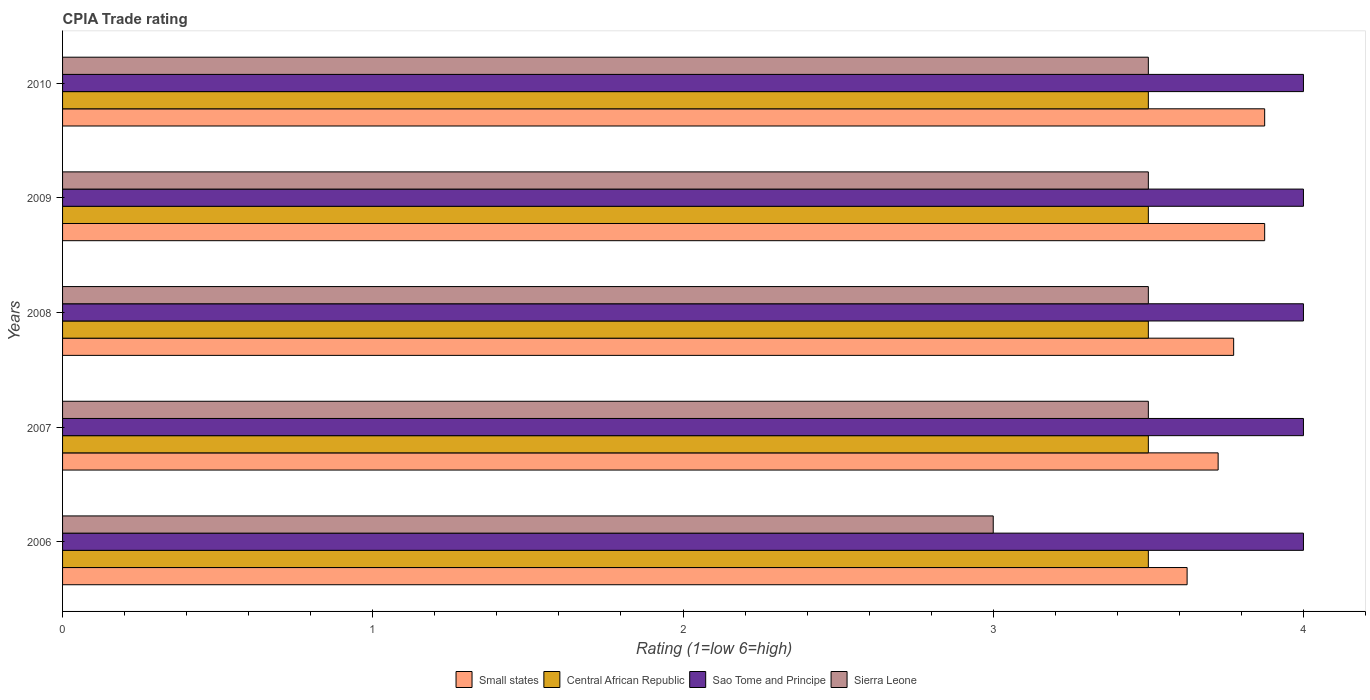How many different coloured bars are there?
Your answer should be compact. 4. How many groups of bars are there?
Your response must be concise. 5. Are the number of bars per tick equal to the number of legend labels?
Give a very brief answer. Yes. How many bars are there on the 1st tick from the top?
Keep it short and to the point. 4. What is the label of the 4th group of bars from the top?
Ensure brevity in your answer.  2007. In how many cases, is the number of bars for a given year not equal to the number of legend labels?
Offer a terse response. 0. What is the CPIA rating in Central African Republic in 2008?
Your answer should be compact. 3.5. Across all years, what is the minimum CPIA rating in Small states?
Your answer should be very brief. 3.62. In which year was the CPIA rating in Small states maximum?
Your answer should be very brief. 2009. In which year was the CPIA rating in Small states minimum?
Your answer should be very brief. 2006. What is the total CPIA rating in Sierra Leone in the graph?
Provide a succinct answer. 17. What is the average CPIA rating in Central African Republic per year?
Offer a very short reply. 3.5. In how many years, is the CPIA rating in Sierra Leone greater than 3.6 ?
Provide a succinct answer. 0. What is the ratio of the CPIA rating in Sierra Leone in 2006 to that in 2007?
Make the answer very short. 0.86. Is it the case that in every year, the sum of the CPIA rating in Central African Republic and CPIA rating in Sao Tome and Principe is greater than the sum of CPIA rating in Sierra Leone and CPIA rating in Small states?
Offer a terse response. Yes. What does the 2nd bar from the top in 2008 represents?
Provide a succinct answer. Sao Tome and Principe. What does the 2nd bar from the bottom in 2009 represents?
Make the answer very short. Central African Republic. How many bars are there?
Offer a very short reply. 20. Does the graph contain grids?
Provide a short and direct response. No. Where does the legend appear in the graph?
Give a very brief answer. Bottom center. How many legend labels are there?
Your answer should be very brief. 4. What is the title of the graph?
Keep it short and to the point. CPIA Trade rating. What is the label or title of the Y-axis?
Keep it short and to the point. Years. What is the Rating (1=low 6=high) in Small states in 2006?
Your response must be concise. 3.62. What is the Rating (1=low 6=high) in Sao Tome and Principe in 2006?
Offer a very short reply. 4. What is the Rating (1=low 6=high) in Sierra Leone in 2006?
Keep it short and to the point. 3. What is the Rating (1=low 6=high) of Small states in 2007?
Offer a very short reply. 3.73. What is the Rating (1=low 6=high) of Central African Republic in 2007?
Make the answer very short. 3.5. What is the Rating (1=low 6=high) in Small states in 2008?
Ensure brevity in your answer.  3.77. What is the Rating (1=low 6=high) in Central African Republic in 2008?
Offer a very short reply. 3.5. What is the Rating (1=low 6=high) of Sierra Leone in 2008?
Your response must be concise. 3.5. What is the Rating (1=low 6=high) in Small states in 2009?
Your answer should be very brief. 3.88. What is the Rating (1=low 6=high) in Central African Republic in 2009?
Keep it short and to the point. 3.5. What is the Rating (1=low 6=high) in Small states in 2010?
Your answer should be compact. 3.88. What is the Rating (1=low 6=high) of Central African Republic in 2010?
Offer a terse response. 3.5. What is the Rating (1=low 6=high) in Sierra Leone in 2010?
Ensure brevity in your answer.  3.5. Across all years, what is the maximum Rating (1=low 6=high) of Small states?
Your answer should be compact. 3.88. Across all years, what is the maximum Rating (1=low 6=high) of Sierra Leone?
Provide a short and direct response. 3.5. Across all years, what is the minimum Rating (1=low 6=high) of Small states?
Keep it short and to the point. 3.62. Across all years, what is the minimum Rating (1=low 6=high) in Central African Republic?
Keep it short and to the point. 3.5. Across all years, what is the minimum Rating (1=low 6=high) in Sao Tome and Principe?
Give a very brief answer. 4. Across all years, what is the minimum Rating (1=low 6=high) of Sierra Leone?
Give a very brief answer. 3. What is the total Rating (1=low 6=high) in Small states in the graph?
Keep it short and to the point. 18.88. What is the total Rating (1=low 6=high) in Sao Tome and Principe in the graph?
Your answer should be very brief. 20. What is the difference between the Rating (1=low 6=high) of Small states in 2006 and that in 2007?
Your answer should be compact. -0.1. What is the difference between the Rating (1=low 6=high) of Sao Tome and Principe in 2006 and that in 2007?
Provide a succinct answer. 0. What is the difference between the Rating (1=low 6=high) of Sierra Leone in 2006 and that in 2007?
Provide a short and direct response. -0.5. What is the difference between the Rating (1=low 6=high) of Small states in 2006 and that in 2008?
Your answer should be very brief. -0.15. What is the difference between the Rating (1=low 6=high) of Central African Republic in 2006 and that in 2008?
Ensure brevity in your answer.  0. What is the difference between the Rating (1=low 6=high) in Sao Tome and Principe in 2006 and that in 2008?
Provide a succinct answer. 0. What is the difference between the Rating (1=low 6=high) of Sierra Leone in 2006 and that in 2008?
Make the answer very short. -0.5. What is the difference between the Rating (1=low 6=high) of Small states in 2006 and that in 2009?
Keep it short and to the point. -0.25. What is the difference between the Rating (1=low 6=high) of Sao Tome and Principe in 2006 and that in 2009?
Offer a very short reply. 0. What is the difference between the Rating (1=low 6=high) of Sierra Leone in 2006 and that in 2009?
Your answer should be compact. -0.5. What is the difference between the Rating (1=low 6=high) of Small states in 2006 and that in 2010?
Your answer should be very brief. -0.25. What is the difference between the Rating (1=low 6=high) in Central African Republic in 2006 and that in 2010?
Provide a succinct answer. 0. What is the difference between the Rating (1=low 6=high) of Sierra Leone in 2007 and that in 2008?
Provide a succinct answer. 0. What is the difference between the Rating (1=low 6=high) in Sao Tome and Principe in 2007 and that in 2009?
Offer a terse response. 0. What is the difference between the Rating (1=low 6=high) of Central African Republic in 2007 and that in 2010?
Keep it short and to the point. 0. What is the difference between the Rating (1=low 6=high) in Central African Republic in 2008 and that in 2009?
Make the answer very short. 0. What is the difference between the Rating (1=low 6=high) in Small states in 2008 and that in 2010?
Your response must be concise. -0.1. What is the difference between the Rating (1=low 6=high) of Sao Tome and Principe in 2008 and that in 2010?
Offer a terse response. 0. What is the difference between the Rating (1=low 6=high) of Central African Republic in 2009 and that in 2010?
Keep it short and to the point. 0. What is the difference between the Rating (1=low 6=high) of Sierra Leone in 2009 and that in 2010?
Provide a short and direct response. 0. What is the difference between the Rating (1=low 6=high) in Small states in 2006 and the Rating (1=low 6=high) in Central African Republic in 2007?
Make the answer very short. 0.12. What is the difference between the Rating (1=low 6=high) of Small states in 2006 and the Rating (1=low 6=high) of Sao Tome and Principe in 2007?
Give a very brief answer. -0.38. What is the difference between the Rating (1=low 6=high) in Small states in 2006 and the Rating (1=low 6=high) in Sierra Leone in 2007?
Offer a terse response. 0.12. What is the difference between the Rating (1=low 6=high) in Central African Republic in 2006 and the Rating (1=low 6=high) in Sao Tome and Principe in 2007?
Your answer should be very brief. -0.5. What is the difference between the Rating (1=low 6=high) in Small states in 2006 and the Rating (1=low 6=high) in Sao Tome and Principe in 2008?
Make the answer very short. -0.38. What is the difference between the Rating (1=low 6=high) of Central African Republic in 2006 and the Rating (1=low 6=high) of Sierra Leone in 2008?
Offer a terse response. 0. What is the difference between the Rating (1=low 6=high) of Small states in 2006 and the Rating (1=low 6=high) of Sao Tome and Principe in 2009?
Make the answer very short. -0.38. What is the difference between the Rating (1=low 6=high) in Small states in 2006 and the Rating (1=low 6=high) in Sierra Leone in 2009?
Your answer should be very brief. 0.12. What is the difference between the Rating (1=low 6=high) of Small states in 2006 and the Rating (1=low 6=high) of Sao Tome and Principe in 2010?
Offer a terse response. -0.38. What is the difference between the Rating (1=low 6=high) in Small states in 2006 and the Rating (1=low 6=high) in Sierra Leone in 2010?
Provide a succinct answer. 0.12. What is the difference between the Rating (1=low 6=high) of Central African Republic in 2006 and the Rating (1=low 6=high) of Sao Tome and Principe in 2010?
Offer a very short reply. -0.5. What is the difference between the Rating (1=low 6=high) in Central African Republic in 2006 and the Rating (1=low 6=high) in Sierra Leone in 2010?
Give a very brief answer. 0. What is the difference between the Rating (1=low 6=high) in Sao Tome and Principe in 2006 and the Rating (1=low 6=high) in Sierra Leone in 2010?
Your response must be concise. 0.5. What is the difference between the Rating (1=low 6=high) of Small states in 2007 and the Rating (1=low 6=high) of Central African Republic in 2008?
Make the answer very short. 0.23. What is the difference between the Rating (1=low 6=high) in Small states in 2007 and the Rating (1=low 6=high) in Sao Tome and Principe in 2008?
Keep it short and to the point. -0.28. What is the difference between the Rating (1=low 6=high) of Small states in 2007 and the Rating (1=low 6=high) of Sierra Leone in 2008?
Ensure brevity in your answer.  0.23. What is the difference between the Rating (1=low 6=high) of Central African Republic in 2007 and the Rating (1=low 6=high) of Sao Tome and Principe in 2008?
Provide a short and direct response. -0.5. What is the difference between the Rating (1=low 6=high) in Central African Republic in 2007 and the Rating (1=low 6=high) in Sierra Leone in 2008?
Ensure brevity in your answer.  0. What is the difference between the Rating (1=low 6=high) of Small states in 2007 and the Rating (1=low 6=high) of Central African Republic in 2009?
Make the answer very short. 0.23. What is the difference between the Rating (1=low 6=high) of Small states in 2007 and the Rating (1=low 6=high) of Sao Tome and Principe in 2009?
Your answer should be very brief. -0.28. What is the difference between the Rating (1=low 6=high) in Small states in 2007 and the Rating (1=low 6=high) in Sierra Leone in 2009?
Your response must be concise. 0.23. What is the difference between the Rating (1=low 6=high) of Sao Tome and Principe in 2007 and the Rating (1=low 6=high) of Sierra Leone in 2009?
Offer a terse response. 0.5. What is the difference between the Rating (1=low 6=high) in Small states in 2007 and the Rating (1=low 6=high) in Central African Republic in 2010?
Provide a succinct answer. 0.23. What is the difference between the Rating (1=low 6=high) in Small states in 2007 and the Rating (1=low 6=high) in Sao Tome and Principe in 2010?
Ensure brevity in your answer.  -0.28. What is the difference between the Rating (1=low 6=high) of Small states in 2007 and the Rating (1=low 6=high) of Sierra Leone in 2010?
Offer a very short reply. 0.23. What is the difference between the Rating (1=low 6=high) in Central African Republic in 2007 and the Rating (1=low 6=high) in Sierra Leone in 2010?
Offer a terse response. 0. What is the difference between the Rating (1=low 6=high) of Small states in 2008 and the Rating (1=low 6=high) of Central African Republic in 2009?
Provide a short and direct response. 0.28. What is the difference between the Rating (1=low 6=high) in Small states in 2008 and the Rating (1=low 6=high) in Sao Tome and Principe in 2009?
Offer a very short reply. -0.23. What is the difference between the Rating (1=low 6=high) in Small states in 2008 and the Rating (1=low 6=high) in Sierra Leone in 2009?
Your answer should be compact. 0.28. What is the difference between the Rating (1=low 6=high) in Central African Republic in 2008 and the Rating (1=low 6=high) in Sao Tome and Principe in 2009?
Give a very brief answer. -0.5. What is the difference between the Rating (1=low 6=high) in Small states in 2008 and the Rating (1=low 6=high) in Central African Republic in 2010?
Keep it short and to the point. 0.28. What is the difference between the Rating (1=low 6=high) of Small states in 2008 and the Rating (1=low 6=high) of Sao Tome and Principe in 2010?
Offer a very short reply. -0.23. What is the difference between the Rating (1=low 6=high) of Small states in 2008 and the Rating (1=low 6=high) of Sierra Leone in 2010?
Make the answer very short. 0.28. What is the difference between the Rating (1=low 6=high) of Sao Tome and Principe in 2008 and the Rating (1=low 6=high) of Sierra Leone in 2010?
Offer a terse response. 0.5. What is the difference between the Rating (1=low 6=high) in Small states in 2009 and the Rating (1=low 6=high) in Central African Republic in 2010?
Make the answer very short. 0.38. What is the difference between the Rating (1=low 6=high) of Small states in 2009 and the Rating (1=low 6=high) of Sao Tome and Principe in 2010?
Make the answer very short. -0.12. What is the difference between the Rating (1=low 6=high) of Central African Republic in 2009 and the Rating (1=low 6=high) of Sao Tome and Principe in 2010?
Your response must be concise. -0.5. What is the difference between the Rating (1=low 6=high) of Sao Tome and Principe in 2009 and the Rating (1=low 6=high) of Sierra Leone in 2010?
Offer a terse response. 0.5. What is the average Rating (1=low 6=high) of Small states per year?
Your answer should be compact. 3.77. What is the average Rating (1=low 6=high) in Sierra Leone per year?
Your response must be concise. 3.4. In the year 2006, what is the difference between the Rating (1=low 6=high) of Small states and Rating (1=low 6=high) of Central African Republic?
Ensure brevity in your answer.  0.12. In the year 2006, what is the difference between the Rating (1=low 6=high) of Small states and Rating (1=low 6=high) of Sao Tome and Principe?
Make the answer very short. -0.38. In the year 2006, what is the difference between the Rating (1=low 6=high) of Central African Republic and Rating (1=low 6=high) of Sao Tome and Principe?
Keep it short and to the point. -0.5. In the year 2007, what is the difference between the Rating (1=low 6=high) of Small states and Rating (1=low 6=high) of Central African Republic?
Make the answer very short. 0.23. In the year 2007, what is the difference between the Rating (1=low 6=high) in Small states and Rating (1=low 6=high) in Sao Tome and Principe?
Your response must be concise. -0.28. In the year 2007, what is the difference between the Rating (1=low 6=high) of Small states and Rating (1=low 6=high) of Sierra Leone?
Ensure brevity in your answer.  0.23. In the year 2007, what is the difference between the Rating (1=low 6=high) of Central African Republic and Rating (1=low 6=high) of Sao Tome and Principe?
Provide a short and direct response. -0.5. In the year 2007, what is the difference between the Rating (1=low 6=high) in Central African Republic and Rating (1=low 6=high) in Sierra Leone?
Provide a succinct answer. 0. In the year 2007, what is the difference between the Rating (1=low 6=high) in Sao Tome and Principe and Rating (1=low 6=high) in Sierra Leone?
Provide a short and direct response. 0.5. In the year 2008, what is the difference between the Rating (1=low 6=high) in Small states and Rating (1=low 6=high) in Central African Republic?
Make the answer very short. 0.28. In the year 2008, what is the difference between the Rating (1=low 6=high) in Small states and Rating (1=low 6=high) in Sao Tome and Principe?
Your response must be concise. -0.23. In the year 2008, what is the difference between the Rating (1=low 6=high) in Small states and Rating (1=low 6=high) in Sierra Leone?
Your answer should be compact. 0.28. In the year 2008, what is the difference between the Rating (1=low 6=high) in Central African Republic and Rating (1=low 6=high) in Sao Tome and Principe?
Your response must be concise. -0.5. In the year 2008, what is the difference between the Rating (1=low 6=high) of Sao Tome and Principe and Rating (1=low 6=high) of Sierra Leone?
Your answer should be compact. 0.5. In the year 2009, what is the difference between the Rating (1=low 6=high) of Small states and Rating (1=low 6=high) of Sao Tome and Principe?
Give a very brief answer. -0.12. In the year 2009, what is the difference between the Rating (1=low 6=high) in Small states and Rating (1=low 6=high) in Sierra Leone?
Offer a very short reply. 0.38. In the year 2009, what is the difference between the Rating (1=low 6=high) of Central African Republic and Rating (1=low 6=high) of Sao Tome and Principe?
Your answer should be very brief. -0.5. In the year 2009, what is the difference between the Rating (1=low 6=high) in Central African Republic and Rating (1=low 6=high) in Sierra Leone?
Provide a short and direct response. 0. In the year 2009, what is the difference between the Rating (1=low 6=high) of Sao Tome and Principe and Rating (1=low 6=high) of Sierra Leone?
Provide a short and direct response. 0.5. In the year 2010, what is the difference between the Rating (1=low 6=high) in Small states and Rating (1=low 6=high) in Central African Republic?
Make the answer very short. 0.38. In the year 2010, what is the difference between the Rating (1=low 6=high) in Small states and Rating (1=low 6=high) in Sao Tome and Principe?
Offer a very short reply. -0.12. In the year 2010, what is the difference between the Rating (1=low 6=high) in Small states and Rating (1=low 6=high) in Sierra Leone?
Your answer should be compact. 0.38. In the year 2010, what is the difference between the Rating (1=low 6=high) of Central African Republic and Rating (1=low 6=high) of Sierra Leone?
Offer a very short reply. 0. In the year 2010, what is the difference between the Rating (1=low 6=high) of Sao Tome and Principe and Rating (1=low 6=high) of Sierra Leone?
Keep it short and to the point. 0.5. What is the ratio of the Rating (1=low 6=high) in Small states in 2006 to that in 2007?
Give a very brief answer. 0.97. What is the ratio of the Rating (1=low 6=high) in Central African Republic in 2006 to that in 2007?
Keep it short and to the point. 1. What is the ratio of the Rating (1=low 6=high) in Small states in 2006 to that in 2008?
Your response must be concise. 0.96. What is the ratio of the Rating (1=low 6=high) of Sao Tome and Principe in 2006 to that in 2008?
Give a very brief answer. 1. What is the ratio of the Rating (1=low 6=high) of Sierra Leone in 2006 to that in 2008?
Ensure brevity in your answer.  0.86. What is the ratio of the Rating (1=low 6=high) of Small states in 2006 to that in 2009?
Ensure brevity in your answer.  0.94. What is the ratio of the Rating (1=low 6=high) of Central African Republic in 2006 to that in 2009?
Keep it short and to the point. 1. What is the ratio of the Rating (1=low 6=high) in Sierra Leone in 2006 to that in 2009?
Give a very brief answer. 0.86. What is the ratio of the Rating (1=low 6=high) in Small states in 2006 to that in 2010?
Your answer should be very brief. 0.94. What is the ratio of the Rating (1=low 6=high) of Central African Republic in 2006 to that in 2010?
Your response must be concise. 1. What is the ratio of the Rating (1=low 6=high) of Small states in 2007 to that in 2008?
Make the answer very short. 0.99. What is the ratio of the Rating (1=low 6=high) in Sao Tome and Principe in 2007 to that in 2008?
Make the answer very short. 1. What is the ratio of the Rating (1=low 6=high) in Sierra Leone in 2007 to that in 2008?
Offer a terse response. 1. What is the ratio of the Rating (1=low 6=high) of Small states in 2007 to that in 2009?
Provide a succinct answer. 0.96. What is the ratio of the Rating (1=low 6=high) in Central African Republic in 2007 to that in 2009?
Give a very brief answer. 1. What is the ratio of the Rating (1=low 6=high) of Small states in 2007 to that in 2010?
Keep it short and to the point. 0.96. What is the ratio of the Rating (1=low 6=high) of Central African Republic in 2007 to that in 2010?
Make the answer very short. 1. What is the ratio of the Rating (1=low 6=high) of Sao Tome and Principe in 2007 to that in 2010?
Offer a terse response. 1. What is the ratio of the Rating (1=low 6=high) of Sierra Leone in 2007 to that in 2010?
Offer a very short reply. 1. What is the ratio of the Rating (1=low 6=high) in Small states in 2008 to that in 2009?
Make the answer very short. 0.97. What is the ratio of the Rating (1=low 6=high) of Sierra Leone in 2008 to that in 2009?
Your answer should be compact. 1. What is the ratio of the Rating (1=low 6=high) in Small states in 2008 to that in 2010?
Keep it short and to the point. 0.97. What is the ratio of the Rating (1=low 6=high) in Central African Republic in 2008 to that in 2010?
Your response must be concise. 1. What is the ratio of the Rating (1=low 6=high) of Sao Tome and Principe in 2008 to that in 2010?
Give a very brief answer. 1. What is the ratio of the Rating (1=low 6=high) in Small states in 2009 to that in 2010?
Your response must be concise. 1. What is the ratio of the Rating (1=low 6=high) in Sao Tome and Principe in 2009 to that in 2010?
Keep it short and to the point. 1. What is the difference between the highest and the second highest Rating (1=low 6=high) of Small states?
Your answer should be very brief. 0. What is the difference between the highest and the second highest Rating (1=low 6=high) of Sierra Leone?
Offer a very short reply. 0. What is the difference between the highest and the lowest Rating (1=low 6=high) in Small states?
Provide a succinct answer. 0.25. What is the difference between the highest and the lowest Rating (1=low 6=high) of Sao Tome and Principe?
Give a very brief answer. 0. What is the difference between the highest and the lowest Rating (1=low 6=high) of Sierra Leone?
Your response must be concise. 0.5. 